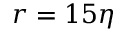<formula> <loc_0><loc_0><loc_500><loc_500>r = 1 5 \eta</formula> 